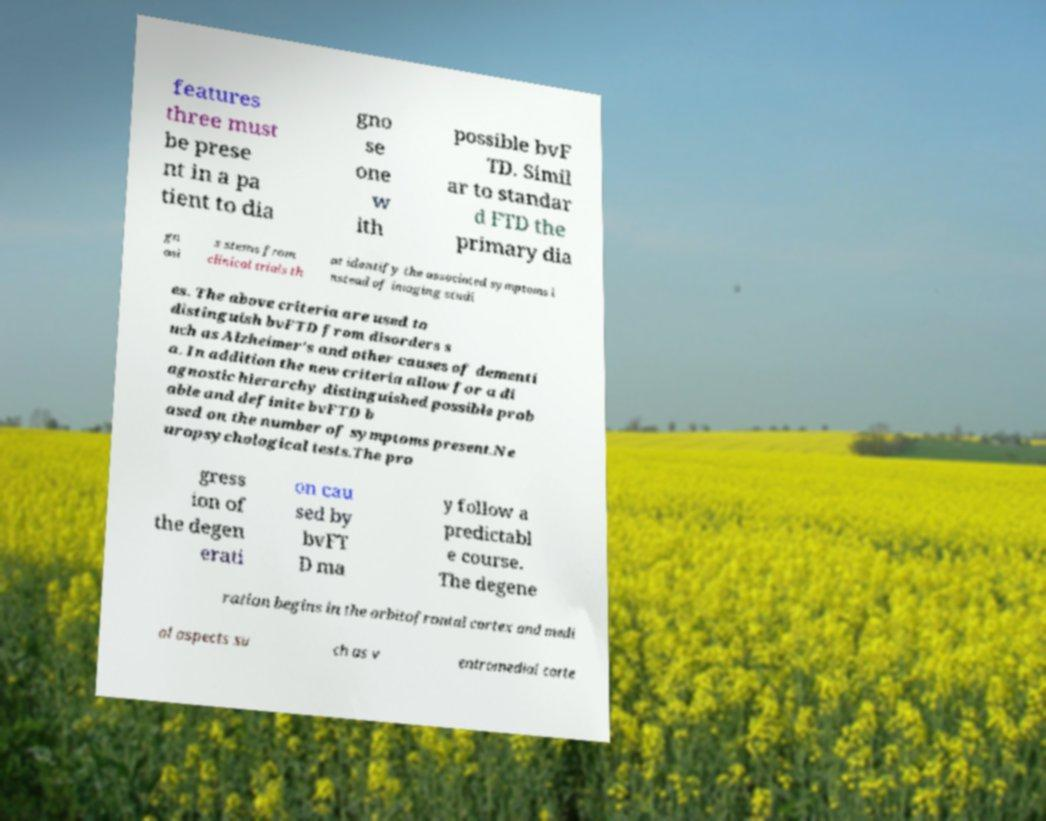Can you read and provide the text displayed in the image?This photo seems to have some interesting text. Can you extract and type it out for me? features three must be prese nt in a pa tient to dia gno se one w ith possible bvF TD. Simil ar to standar d FTD the primary dia gn osi s stems from clinical trials th at identify the associated symptoms i nstead of imaging studi es. The above criteria are used to distinguish bvFTD from disorders s uch as Alzheimer's and other causes of dementi a. In addition the new criteria allow for a di agnostic hierarchy distinguished possible prob able and definite bvFTD b ased on the number of symptoms present.Ne uropsychological tests.The pro gress ion of the degen erati on cau sed by bvFT D ma y follow a predictabl e course. The degene ration begins in the orbitofrontal cortex and medi al aspects su ch as v entromedial corte 